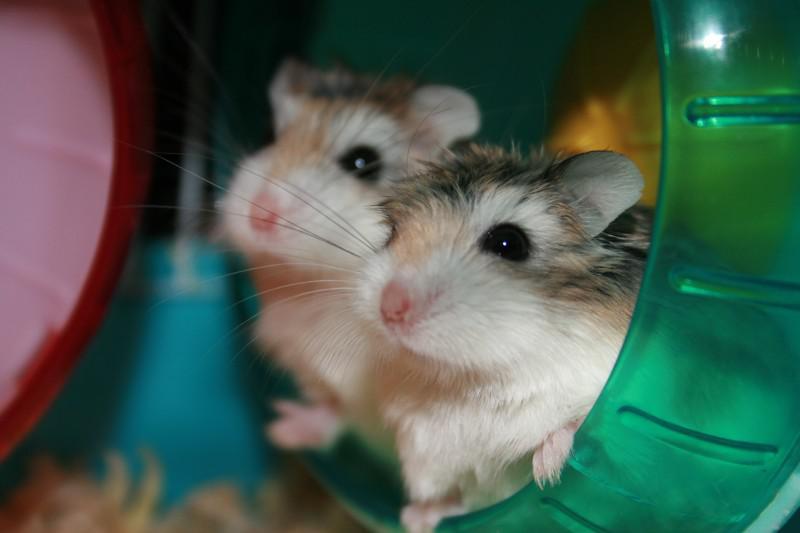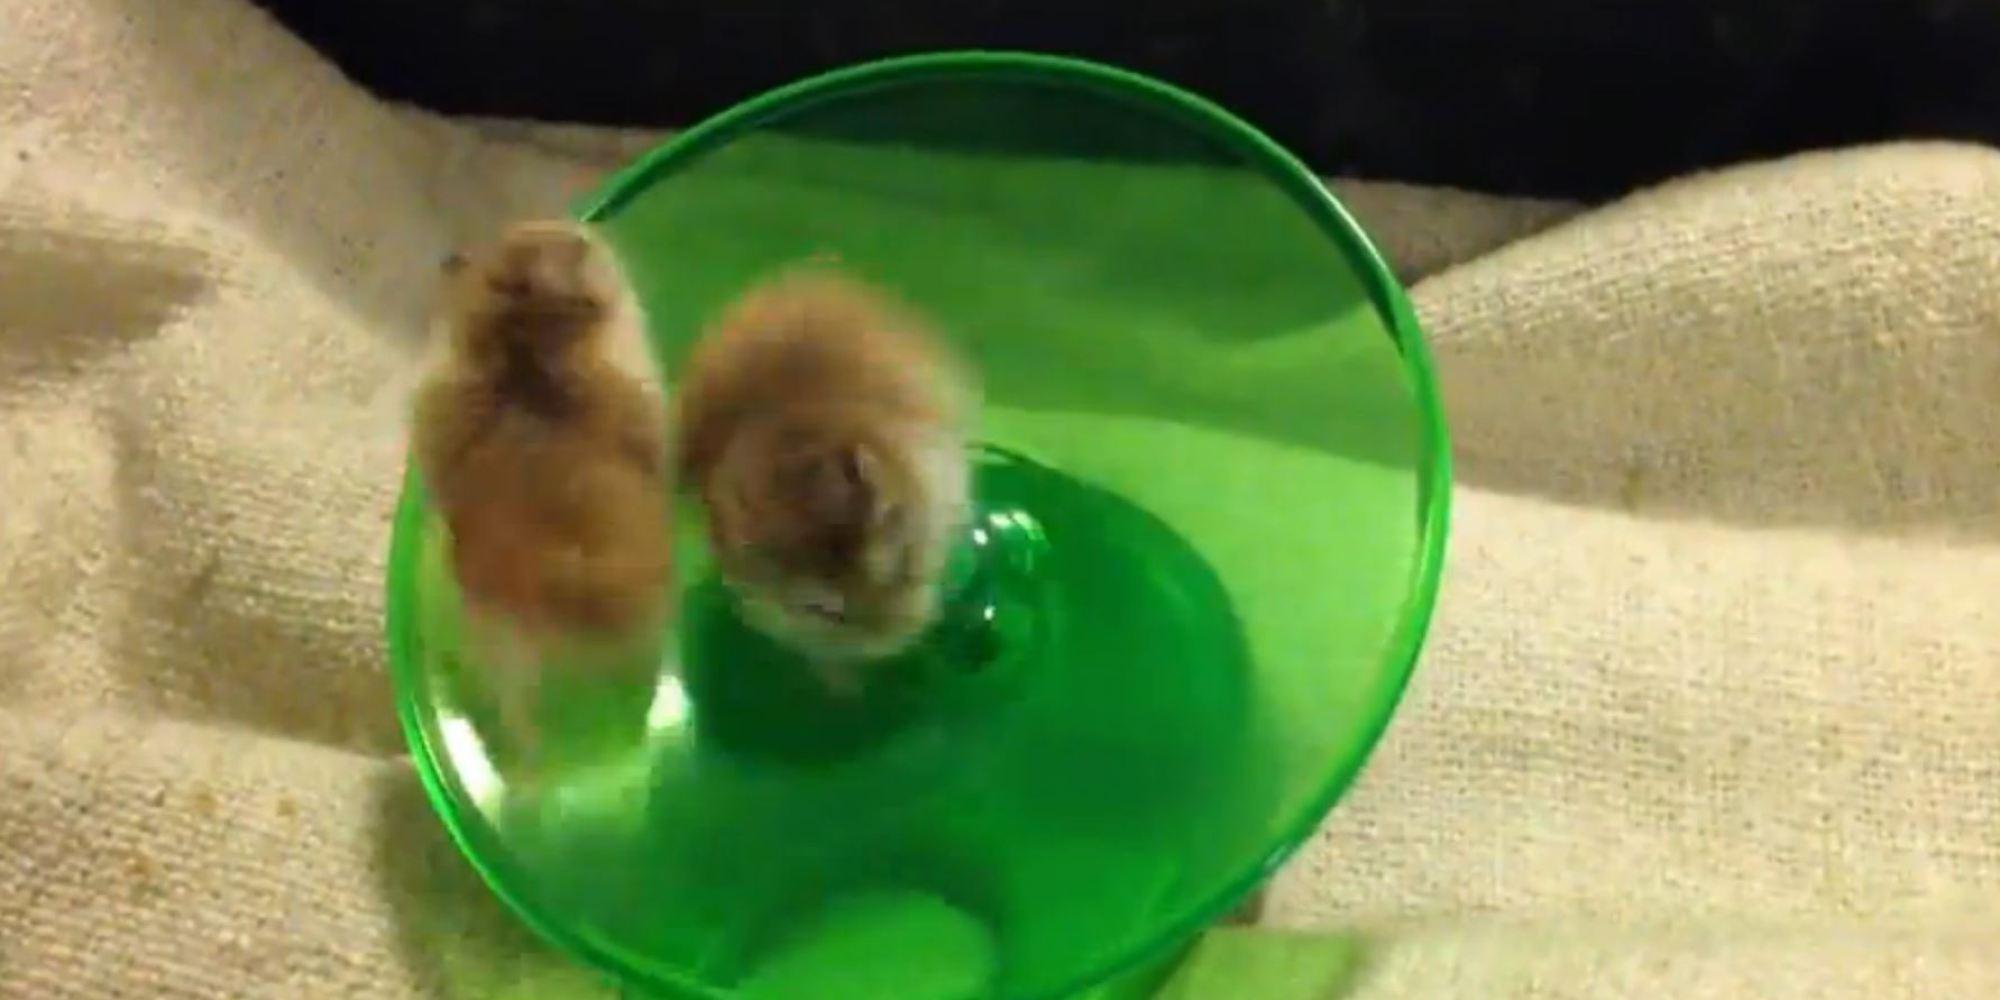The first image is the image on the left, the second image is the image on the right. For the images shown, is this caption "At least one image shows only one hamster." true? Answer yes or no. No. The first image is the image on the left, the second image is the image on the right. Examine the images to the left and right. Is the description "The images contain a total of four hamsters that are on a plastic object." accurate? Answer yes or no. Yes. 